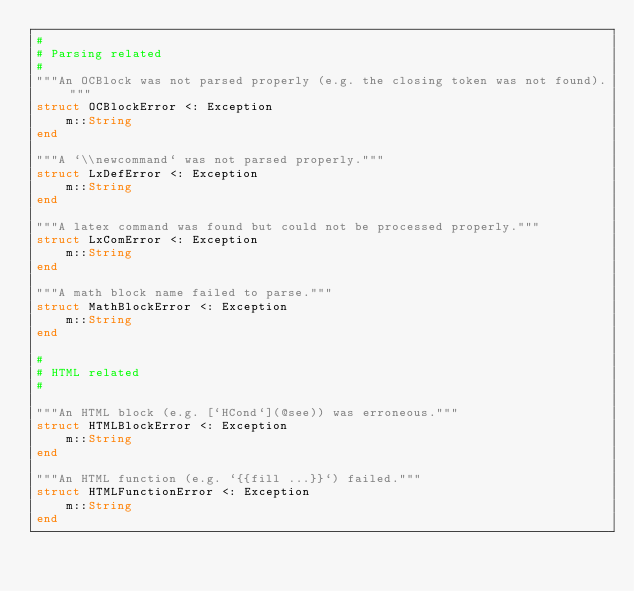<code> <loc_0><loc_0><loc_500><loc_500><_Julia_>#
# Parsing related
#
"""An OCBlock was not parsed properly (e.g. the closing token was not found)."""
struct OCBlockError <: Exception
    m::String
end

"""A `\\newcommand` was not parsed properly."""
struct LxDefError <: Exception
    m::String
end

"""A latex command was found but could not be processed properly."""
struct LxComError <: Exception
    m::String
end

"""A math block name failed to parse."""
struct MathBlockError <: Exception
    m::String
end

#
# HTML related
#

"""An HTML block (e.g. [`HCond`](@see)) was erroneous."""
struct HTMLBlockError <: Exception
    m::String
end

"""An HTML function (e.g. `{{fill ...}}`) failed."""
struct HTMLFunctionError <: Exception
    m::String
end
</code> 